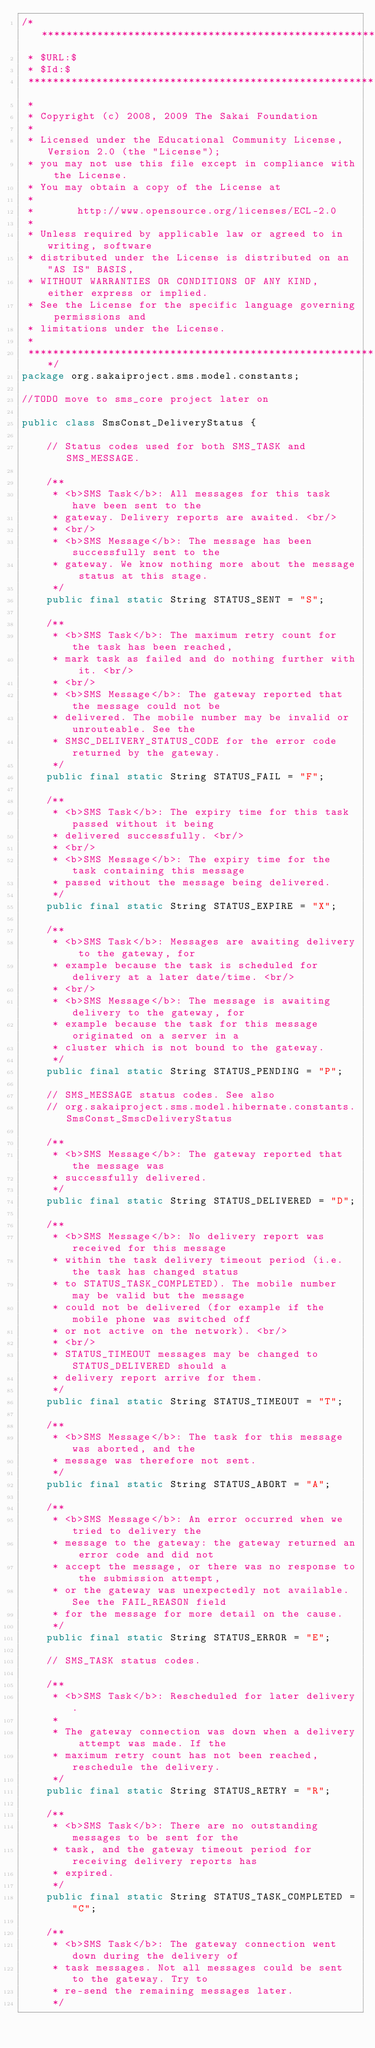<code> <loc_0><loc_0><loc_500><loc_500><_Java_>/**********************************************************************************
 * $URL:$
 * $Id:$
 ***********************************************************************************
 *
 * Copyright (c) 2008, 2009 The Sakai Foundation
 *
 * Licensed under the Educational Community License, Version 2.0 (the "License");
 * you may not use this file except in compliance with the License.
 * You may obtain a copy of the License at
 *
 *       http://www.opensource.org/licenses/ECL-2.0
 *
 * Unless required by applicable law or agreed to in writing, software
 * distributed under the License is distributed on an "AS IS" BASIS,
 * WITHOUT WARRANTIES OR CONDITIONS OF ANY KIND, either express or implied.
 * See the License for the specific language governing permissions and
 * limitations under the License.
 *
 **********************************************************************************/
package org.sakaiproject.sms.model.constants;

//TODO move to sms_core project later on

public class SmsConst_DeliveryStatus {

	// Status codes used for both SMS_TASK and SMS_MESSAGE.

	/**
	 * <b>SMS Task</b>: All messages for this task have been sent to the
	 * gateway. Delivery reports are awaited. <br/>
	 * <br/>
	 * <b>SMS Message</b>: The message has been successfully sent to the
	 * gateway. We know nothing more about the message status at this stage.
	 */
	public final static String STATUS_SENT = "S";

	/**
	 * <b>SMS Task</b>: The maximum retry count for the task has been reached,
	 * mark task as failed and do nothing further with it. <br/>
	 * <br/>
	 * <b>SMS Message</b>: The gateway reported that the message could not be
	 * delivered. The mobile number may be invalid or unrouteable. See the
	 * SMSC_DELIVERY_STATUS_CODE for the error code returned by the gateway.
	 */
	public final static String STATUS_FAIL = "F";

	/**
	 * <b>SMS Task</b>: The expiry time for this task passed without it being
	 * delivered successfully. <br/>
	 * <br/>
	 * <b>SMS Message</b>: The expiry time for the task containing this message
	 * passed without the message being delivered.
	 */
	public final static String STATUS_EXPIRE = "X";

	/**
	 * <b>SMS Task</b>: Messages are awaiting delivery to the gateway, for
	 * example because the task is scheduled for delivery at a later date/time. <br/>
	 * <br/>
	 * <b>SMS Message</b>: The message is awaiting delivery to the gateway, for
	 * example because the task for this message originated on a server in a
	 * cluster which is not bound to the gateway.
	 */
	public final static String STATUS_PENDING = "P";

	// SMS_MESSAGE status codes. See also
	// org.sakaiproject.sms.model.hibernate.constants.SmsConst_SmscDeliveryStatus

	/**
	 * <b>SMS Message</b>: The gateway reported that the message was
	 * successfully delivered.
	 */
	public final static String STATUS_DELIVERED = "D";

	/**
	 * <b>SMS Message</b>: No delivery report was received for this message
	 * within the task delivery timeout period (i.e. the task has changed status
	 * to STATUS_TASK_COMPLETED). The mobile number may be valid but the message
	 * could not be delivered (for example if the mobile phone was switched off
	 * or not active on the network). <br/>
	 * <br/>
	 * STATUS_TIMEOUT messages may be changed to STATUS_DELIVERED should a 
	 * delivery report arrive for them.
	 */
	public final static String STATUS_TIMEOUT = "T";

	/**
	 * <b>SMS Message</b>: The task for this message was aborted, and the
	 * message was therefore not sent.
	 */
	public final static String STATUS_ABORT = "A";

	/**
	 * <b>SMS Message</b>: An error occurred when we tried to delivery the
	 * message to the gateway: the gateway returned an error code and did not
	 * accept the message, or there was no response to the submission attempt,
	 * or the gateway was unexpectedly not available. See the FAIL_REASON field
	 * for the message for more detail on the cause.
	 */
	public final static String STATUS_ERROR = "E";

	// SMS_TASK status codes.

	/**
	 * <b>SMS Task</b>: Rescheduled for later delivery.
	 * 
	 * The gateway connection was down when a delivery attempt was made. If the
	 * maximum retry count has not been reached, reschedule the delivery.
	 */
	public final static String STATUS_RETRY = "R";

	/**
	 * <b>SMS Task</b>: There are no outstanding messages to be sent for the
	 * task, and the gateway timeout period for receiving delivery reports has
	 * expired.
	 */
	public final static String STATUS_TASK_COMPLETED = "C";

	/**
	 * <b>SMS Task</b>: The gateway connection went down during the delivery of
	 * task messages. Not all messages could be sent to the gateway. Try to
	 * re-send the remaining messages later.
	 */</code> 